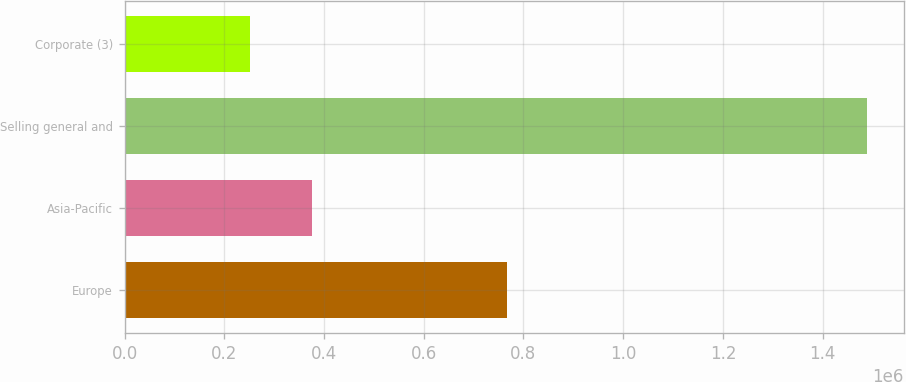Convert chart to OTSL. <chart><loc_0><loc_0><loc_500><loc_500><bar_chart><fcel>Europe<fcel>Asia-Pacific<fcel>Selling general and<fcel>Corporate (3)<nl><fcel>767524<fcel>375790<fcel>1.48826e+06<fcel>252183<nl></chart> 